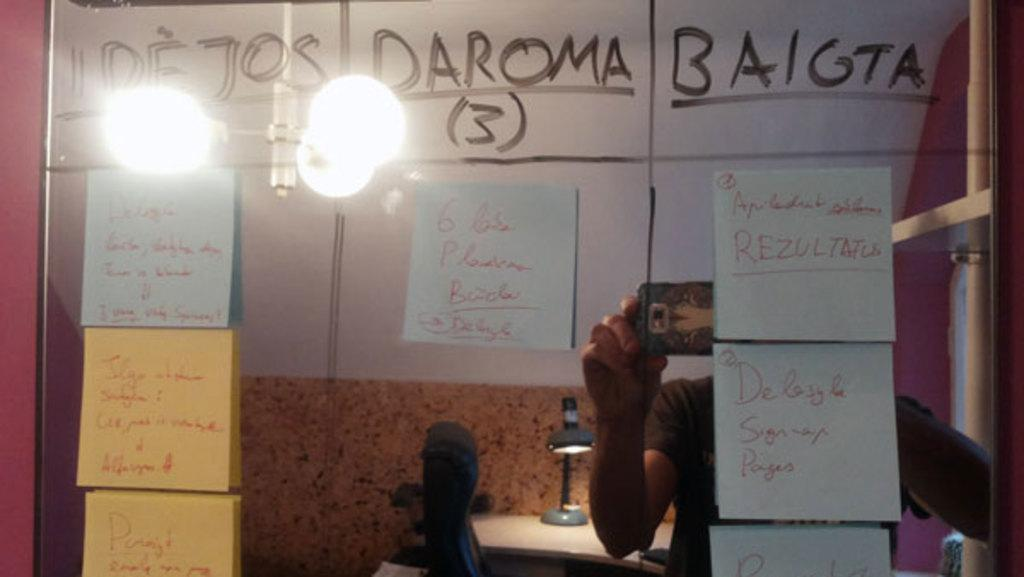What is the main subject in the image? There is a person in the image. What is the person holding in the image? The person is holding a mobile. What can be seen in the background of the image? There is a wall in the background of the image. What type of objects can be seen in the image? There are some objects in the image. What architectural features are present in the image? There are posts in the image. What else is visible in the image? There are lights and a table in the image. What type of chalk is being used to draw on the cabbage in the image? There is no chalk or cabbage present in the image. How many trees can be seen in the image? There are no trees visible in the image. 